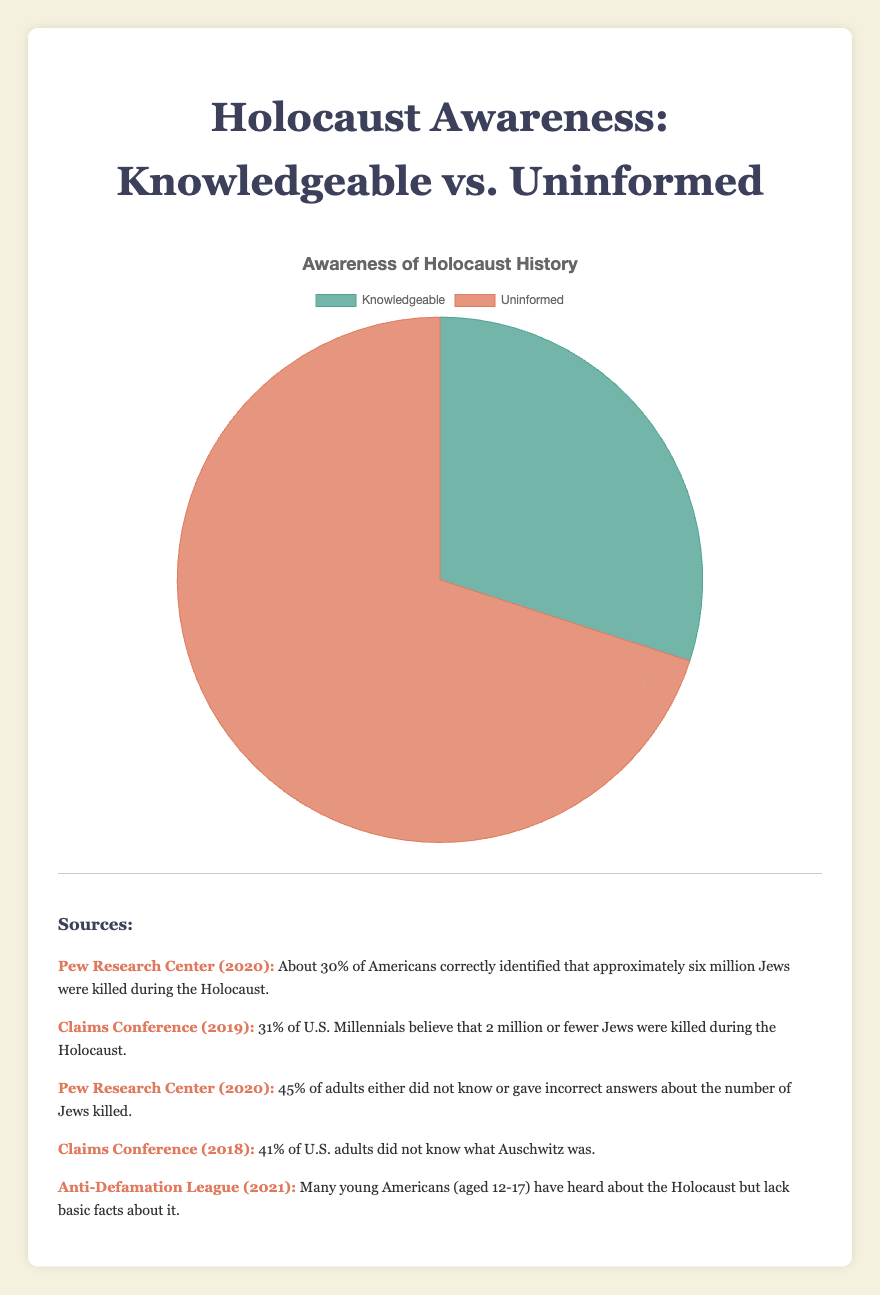What percentage of people are knowledgeable about the Holocaust? To find the percentage of people who are knowledgeable about the Holocaust, we look at the data label "Knowledgeable" in the pie chart, which is 30%.
Answer: 30% What percentage of people are uninformed about the Holocaust? To determine the percentage of people who are uninformed, we refer to the "Uninformed" label in the pie chart, which represents 70%.
Answer: 70% How many times greater is the percentage of uninformed people compared to knowledgeable people? To find the ratio, we divide the percentage of uninformed people (70%) by the percentage of knowledgeable people (30%), which gives us 70 ÷ 30 = 2.33. So, the uninformed percentage is approximately 2.33 times greater than the knowledgeable percentage.
Answer: 2.33 times Which group has the highest percentage, knowledgeable or uninformed? By comparing the two segments of the pie chart, we see that the "Uninformed" segment is larger, representing 70%, which is higher than the "Knowledgeable" segment's 30%.
Answer: Uninformed What is the sum of the percentages of knowledgeable and uninformed groups? We add the percentages for both groups together: 30% (Knowledgeable) + 70% (Uninformed) = 100%.
Answer: 100% How does the color represent different groups in the chart? In the pie chart, the "Knowledgeable" group is represented by a greenish color, while the "Uninformed" group is shown in an orangish color.
Answer: Greenish for Knowledgeable and Orangish for Uninformed By what factor do uninformed people's percentage exceed knowledgeable people’s percentage? To find the factor by which the uninformed percentage exceeds the knowledgeable percentage, we perform the calculation 70 ÷ 30, which equals approximately 2.33.
Answer: 2.33 What is the maximum percentage present in the chart? The pie chart shows the "Uninformed" group with the highest percentage of 70%.
Answer: 70% 